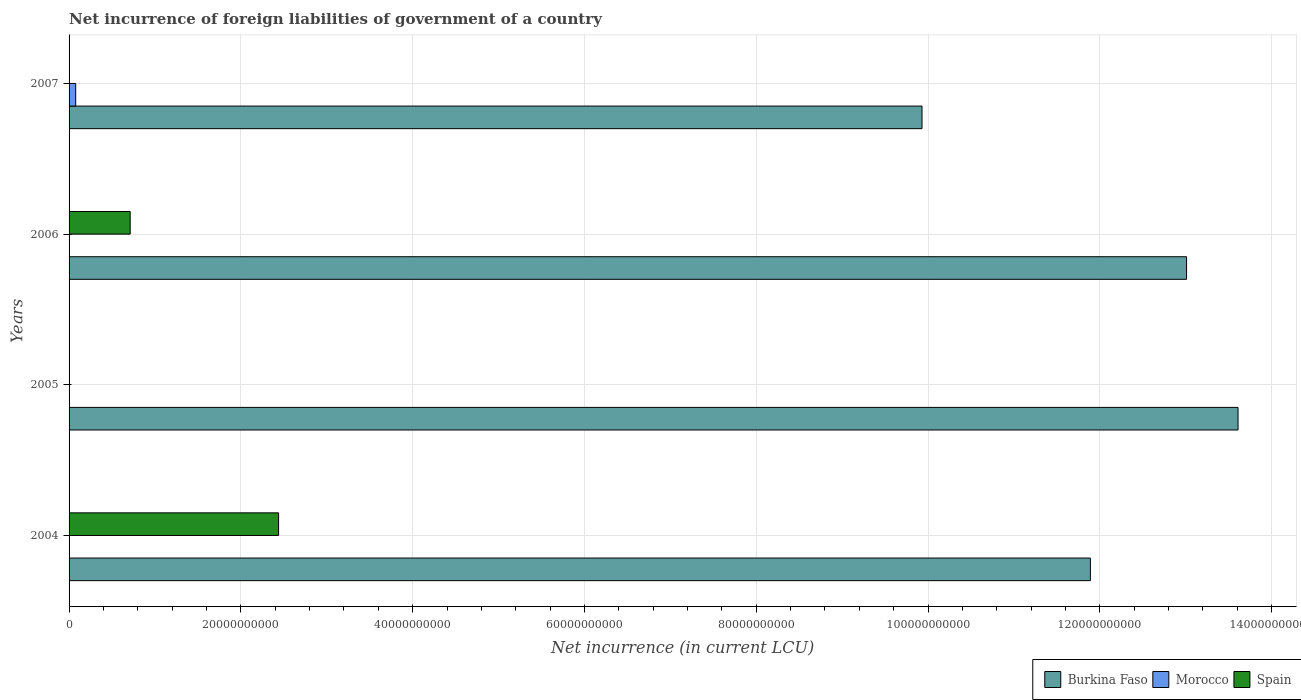Are the number of bars on each tick of the Y-axis equal?
Your answer should be very brief. No. How many bars are there on the 1st tick from the bottom?
Make the answer very short. 2. What is the label of the 2nd group of bars from the top?
Make the answer very short. 2006. What is the net incurrence of foreign liabilities in Burkina Faso in 2007?
Provide a short and direct response. 9.93e+1. Across all years, what is the maximum net incurrence of foreign liabilities in Burkina Faso?
Your response must be concise. 1.36e+11. Across all years, what is the minimum net incurrence of foreign liabilities in Burkina Faso?
Give a very brief answer. 9.93e+1. In which year was the net incurrence of foreign liabilities in Morocco maximum?
Your answer should be compact. 2007. What is the total net incurrence of foreign liabilities in Morocco in the graph?
Your answer should be very brief. 7.73e+08. What is the difference between the net incurrence of foreign liabilities in Burkina Faso in 2005 and that in 2006?
Your answer should be very brief. 5.99e+09. What is the difference between the net incurrence of foreign liabilities in Spain in 2006 and the net incurrence of foreign liabilities in Morocco in 2005?
Offer a terse response. 7.12e+09. What is the average net incurrence of foreign liabilities in Spain per year?
Ensure brevity in your answer.  7.88e+09. In how many years, is the net incurrence of foreign liabilities in Morocco greater than 108000000000 LCU?
Provide a succinct answer. 0. What is the ratio of the net incurrence of foreign liabilities in Burkina Faso in 2006 to that in 2007?
Offer a very short reply. 1.31. What is the difference between the highest and the second highest net incurrence of foreign liabilities in Burkina Faso?
Offer a terse response. 5.99e+09. What is the difference between the highest and the lowest net incurrence of foreign liabilities in Burkina Faso?
Your answer should be very brief. 3.68e+1. In how many years, is the net incurrence of foreign liabilities in Morocco greater than the average net incurrence of foreign liabilities in Morocco taken over all years?
Keep it short and to the point. 1. Are all the bars in the graph horizontal?
Keep it short and to the point. Yes. What is the difference between two consecutive major ticks on the X-axis?
Ensure brevity in your answer.  2.00e+1. Are the values on the major ticks of X-axis written in scientific E-notation?
Your response must be concise. No. Does the graph contain grids?
Keep it short and to the point. Yes. How many legend labels are there?
Keep it short and to the point. 3. How are the legend labels stacked?
Provide a short and direct response. Horizontal. What is the title of the graph?
Keep it short and to the point. Net incurrence of foreign liabilities of government of a country. Does "Benin" appear as one of the legend labels in the graph?
Ensure brevity in your answer.  No. What is the label or title of the X-axis?
Offer a terse response. Net incurrence (in current LCU). What is the label or title of the Y-axis?
Offer a very short reply. Years. What is the Net incurrence (in current LCU) in Burkina Faso in 2004?
Your response must be concise. 1.19e+11. What is the Net incurrence (in current LCU) in Spain in 2004?
Give a very brief answer. 2.44e+1. What is the Net incurrence (in current LCU) of Burkina Faso in 2005?
Provide a succinct answer. 1.36e+11. What is the Net incurrence (in current LCU) in Burkina Faso in 2006?
Offer a very short reply. 1.30e+11. What is the Net incurrence (in current LCU) of Morocco in 2006?
Your answer should be very brief. 0. What is the Net incurrence (in current LCU) in Spain in 2006?
Ensure brevity in your answer.  7.12e+09. What is the Net incurrence (in current LCU) of Burkina Faso in 2007?
Provide a short and direct response. 9.93e+1. What is the Net incurrence (in current LCU) of Morocco in 2007?
Provide a succinct answer. 7.73e+08. Across all years, what is the maximum Net incurrence (in current LCU) of Burkina Faso?
Ensure brevity in your answer.  1.36e+11. Across all years, what is the maximum Net incurrence (in current LCU) of Morocco?
Offer a very short reply. 7.73e+08. Across all years, what is the maximum Net incurrence (in current LCU) of Spain?
Provide a succinct answer. 2.44e+1. Across all years, what is the minimum Net incurrence (in current LCU) of Burkina Faso?
Your answer should be very brief. 9.93e+1. Across all years, what is the minimum Net incurrence (in current LCU) of Morocco?
Your response must be concise. 0. Across all years, what is the minimum Net incurrence (in current LCU) in Spain?
Your response must be concise. 0. What is the total Net incurrence (in current LCU) of Burkina Faso in the graph?
Your response must be concise. 4.84e+11. What is the total Net incurrence (in current LCU) of Morocco in the graph?
Your answer should be very brief. 7.73e+08. What is the total Net incurrence (in current LCU) in Spain in the graph?
Your answer should be compact. 3.15e+1. What is the difference between the Net incurrence (in current LCU) of Burkina Faso in 2004 and that in 2005?
Offer a very short reply. -1.72e+1. What is the difference between the Net incurrence (in current LCU) in Burkina Faso in 2004 and that in 2006?
Keep it short and to the point. -1.12e+1. What is the difference between the Net incurrence (in current LCU) in Spain in 2004 and that in 2006?
Ensure brevity in your answer.  1.73e+1. What is the difference between the Net incurrence (in current LCU) in Burkina Faso in 2004 and that in 2007?
Your answer should be compact. 1.96e+1. What is the difference between the Net incurrence (in current LCU) in Burkina Faso in 2005 and that in 2006?
Your answer should be very brief. 5.99e+09. What is the difference between the Net incurrence (in current LCU) in Burkina Faso in 2005 and that in 2007?
Provide a succinct answer. 3.68e+1. What is the difference between the Net incurrence (in current LCU) in Burkina Faso in 2006 and that in 2007?
Your answer should be compact. 3.08e+1. What is the difference between the Net incurrence (in current LCU) in Burkina Faso in 2004 and the Net incurrence (in current LCU) in Spain in 2006?
Your answer should be compact. 1.12e+11. What is the difference between the Net incurrence (in current LCU) in Burkina Faso in 2004 and the Net incurrence (in current LCU) in Morocco in 2007?
Your answer should be compact. 1.18e+11. What is the difference between the Net incurrence (in current LCU) in Burkina Faso in 2005 and the Net incurrence (in current LCU) in Spain in 2006?
Make the answer very short. 1.29e+11. What is the difference between the Net incurrence (in current LCU) in Burkina Faso in 2005 and the Net incurrence (in current LCU) in Morocco in 2007?
Your response must be concise. 1.35e+11. What is the difference between the Net incurrence (in current LCU) of Burkina Faso in 2006 and the Net incurrence (in current LCU) of Morocco in 2007?
Ensure brevity in your answer.  1.29e+11. What is the average Net incurrence (in current LCU) in Burkina Faso per year?
Offer a terse response. 1.21e+11. What is the average Net incurrence (in current LCU) of Morocco per year?
Provide a succinct answer. 1.93e+08. What is the average Net incurrence (in current LCU) in Spain per year?
Ensure brevity in your answer.  7.88e+09. In the year 2004, what is the difference between the Net incurrence (in current LCU) in Burkina Faso and Net incurrence (in current LCU) in Spain?
Offer a terse response. 9.45e+1. In the year 2006, what is the difference between the Net incurrence (in current LCU) of Burkina Faso and Net incurrence (in current LCU) of Spain?
Give a very brief answer. 1.23e+11. In the year 2007, what is the difference between the Net incurrence (in current LCU) in Burkina Faso and Net incurrence (in current LCU) in Morocco?
Provide a short and direct response. 9.85e+1. What is the ratio of the Net incurrence (in current LCU) of Burkina Faso in 2004 to that in 2005?
Keep it short and to the point. 0.87. What is the ratio of the Net incurrence (in current LCU) of Burkina Faso in 2004 to that in 2006?
Your answer should be compact. 0.91. What is the ratio of the Net incurrence (in current LCU) of Spain in 2004 to that in 2006?
Give a very brief answer. 3.43. What is the ratio of the Net incurrence (in current LCU) of Burkina Faso in 2004 to that in 2007?
Give a very brief answer. 1.2. What is the ratio of the Net incurrence (in current LCU) in Burkina Faso in 2005 to that in 2006?
Make the answer very short. 1.05. What is the ratio of the Net incurrence (in current LCU) in Burkina Faso in 2005 to that in 2007?
Provide a succinct answer. 1.37. What is the ratio of the Net incurrence (in current LCU) of Burkina Faso in 2006 to that in 2007?
Offer a very short reply. 1.31. What is the difference between the highest and the second highest Net incurrence (in current LCU) in Burkina Faso?
Offer a terse response. 5.99e+09. What is the difference between the highest and the lowest Net incurrence (in current LCU) of Burkina Faso?
Offer a very short reply. 3.68e+1. What is the difference between the highest and the lowest Net incurrence (in current LCU) of Morocco?
Ensure brevity in your answer.  7.73e+08. What is the difference between the highest and the lowest Net incurrence (in current LCU) in Spain?
Ensure brevity in your answer.  2.44e+1. 